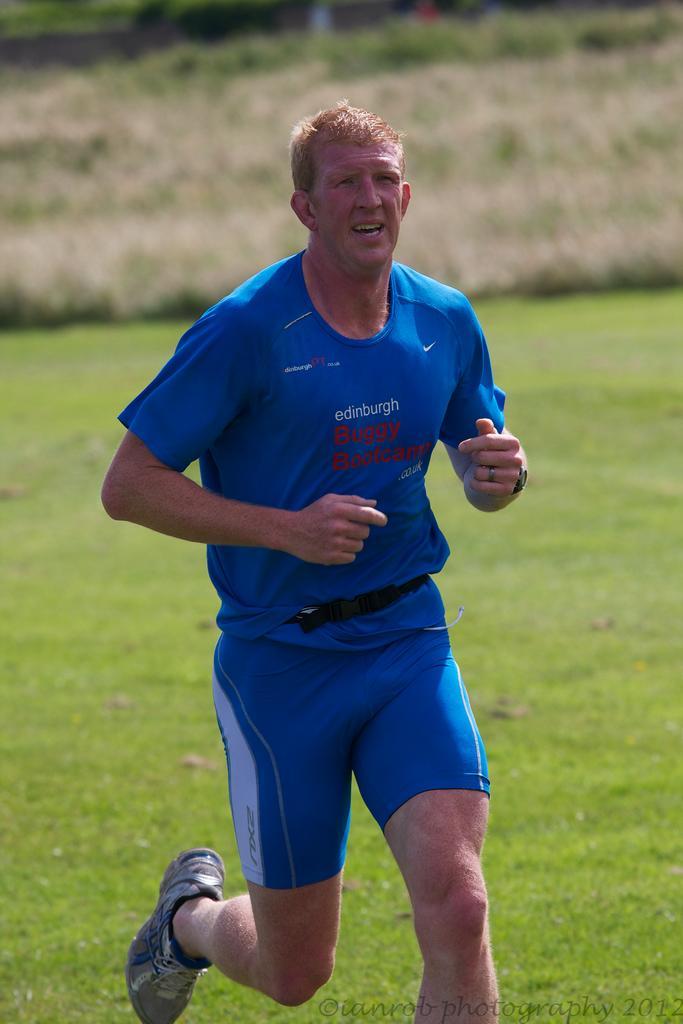Could you give a brief overview of what you see in this image? In this image we can see a man running on the ground. We can also see some grass and a wall. On the bottom of the image we can see some text. 